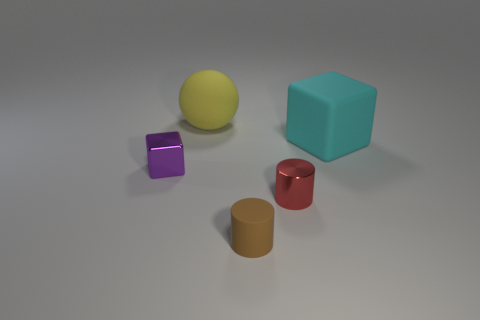Add 5 purple cubes. How many objects exist? 10 Subtract all blocks. How many objects are left? 3 Subtract all big yellow matte balls. Subtract all large blue rubber cylinders. How many objects are left? 4 Add 1 cyan objects. How many cyan objects are left? 2 Add 1 big matte cubes. How many big matte cubes exist? 2 Subtract 1 red cylinders. How many objects are left? 4 